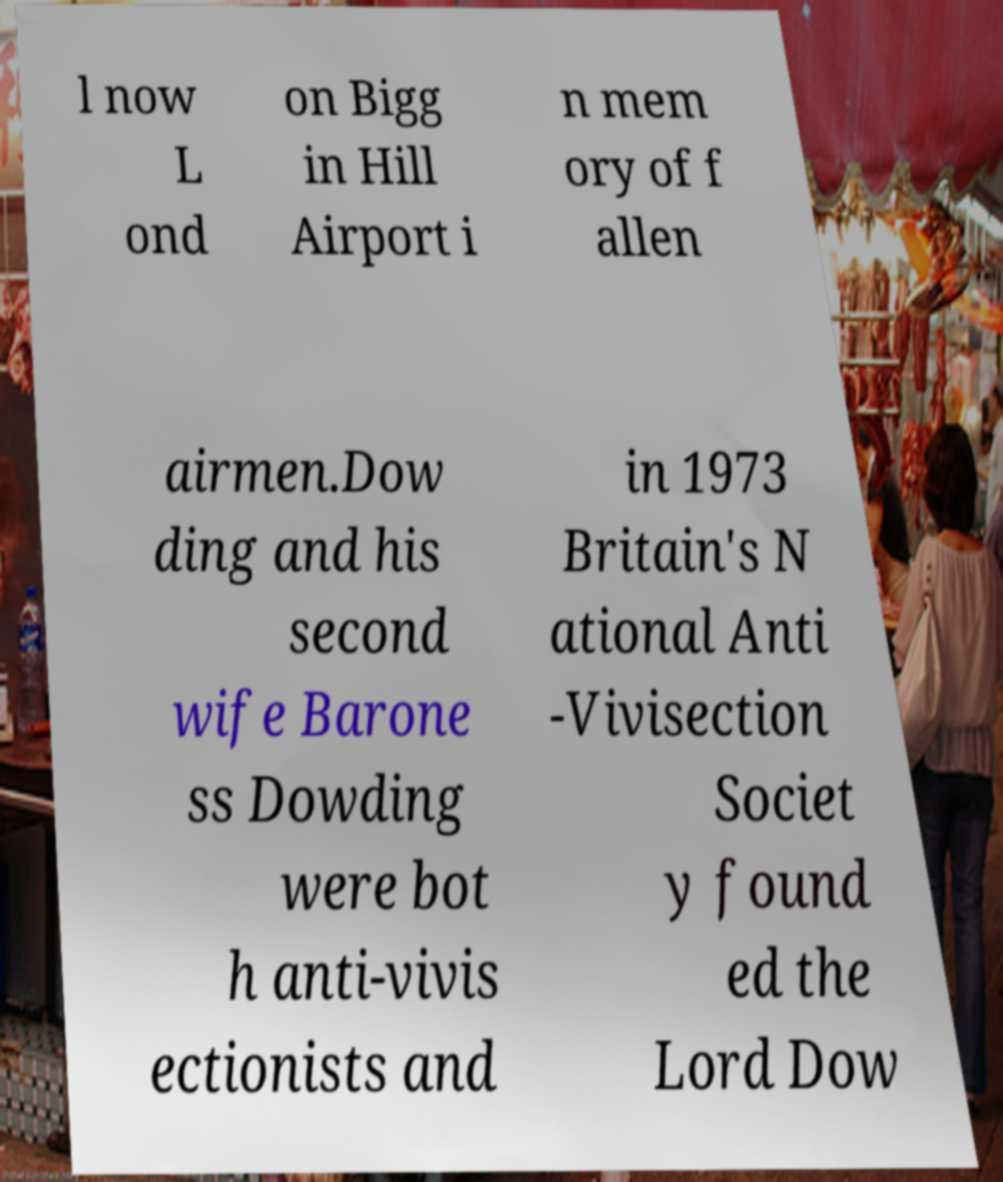I need the written content from this picture converted into text. Can you do that? l now L ond on Bigg in Hill Airport i n mem ory of f allen airmen.Dow ding and his second wife Barone ss Dowding were bot h anti-vivis ectionists and in 1973 Britain's N ational Anti -Vivisection Societ y found ed the Lord Dow 